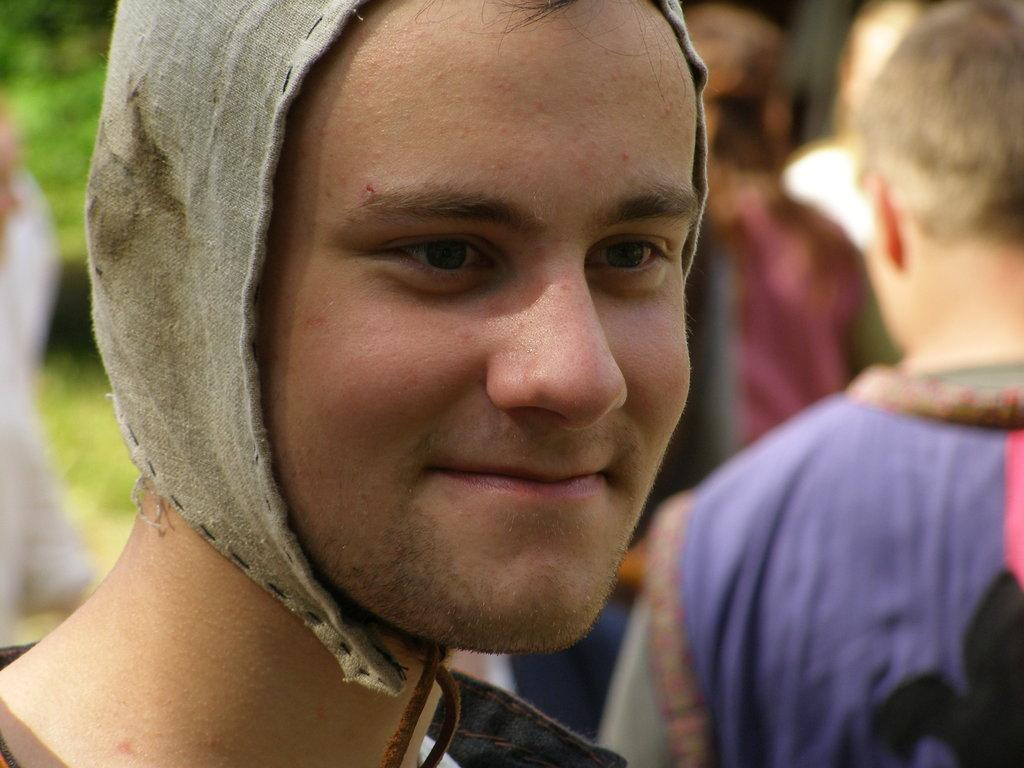Who is present in the image? There is a person in the image. What is the person doing in the image? The person is smiling. Can you describe the surroundings in the image? There are people and greenery in the background of the image. What type of quill is the person holding in the image? There is no quill present in the image. What street can be seen in the background of the image? There is no street visible in the image; it features greenery in the background. 